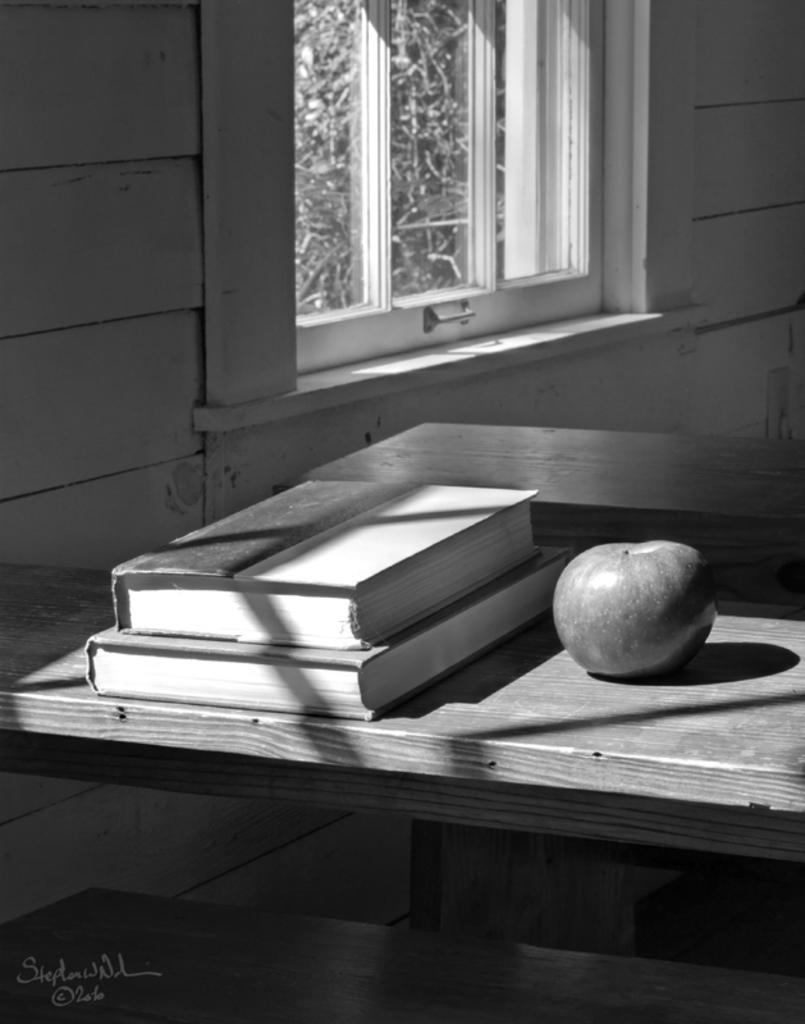What type of structure can be seen in the image? There is a wall in the image. What is a feature of the wall that can be seen in the image? There is a window in the image. What type of furniture is present in the image? There is a table in the image. What type of food is on the table in the image? There is an apple on the table. What type of items are on the table in the image? There are books on the table. Can you tell me how many clovers are depicted on the wall in the image? There are no clovers depicted on the wall in the image. What type of frame is around the window in the image? There is no frame around the window mentioned in the provided facts. What type of natural disaster is happening in the image? There is no indication of any natural disaster, such as an earthquake, happening in the image. 